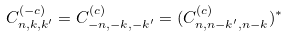Convert formula to latex. <formula><loc_0><loc_0><loc_500><loc_500>C _ { n , k , k ^ { \prime } } ^ { ( - c ) } = C _ { - n , - k , - k ^ { \prime } } ^ { ( c ) } = ( C _ { n , n - k ^ { \prime } , n - k } ^ { ( c ) } ) ^ { * }</formula> 